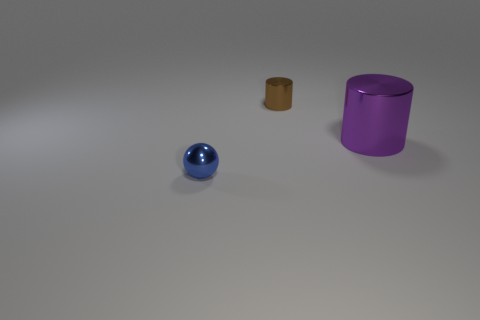Subtract all purple cylinders. Subtract all balls. How many objects are left? 1 Add 1 brown cylinders. How many brown cylinders are left? 2 Add 2 shiny things. How many shiny things exist? 5 Add 2 big gray balls. How many objects exist? 5 Subtract all brown cylinders. How many cylinders are left? 1 Subtract 0 red cylinders. How many objects are left? 3 Subtract all cylinders. How many objects are left? 1 Subtract 2 cylinders. How many cylinders are left? 0 Subtract all cyan cylinders. Subtract all purple spheres. How many cylinders are left? 2 Subtract all purple balls. How many purple cylinders are left? 1 